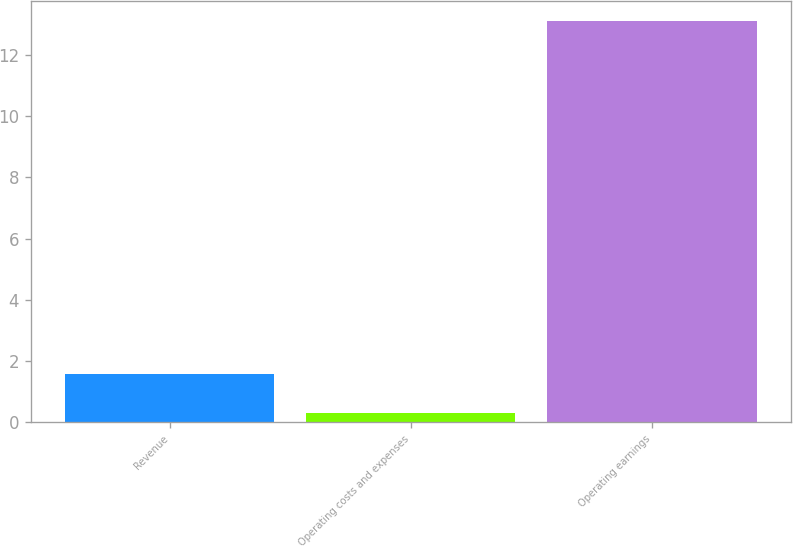Convert chart to OTSL. <chart><loc_0><loc_0><loc_500><loc_500><bar_chart><fcel>Revenue<fcel>Operating costs and expenses<fcel>Operating earnings<nl><fcel>1.58<fcel>0.3<fcel>13.1<nl></chart> 